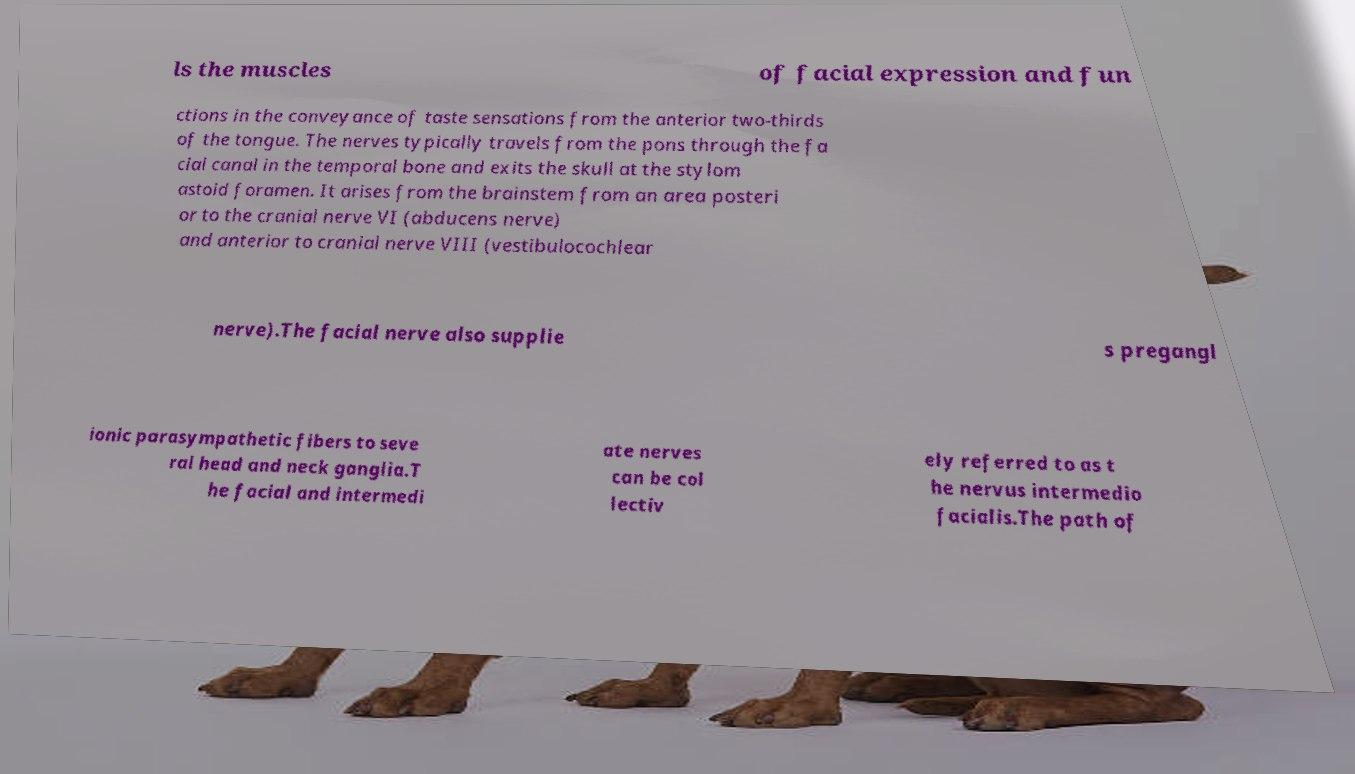Can you accurately transcribe the text from the provided image for me? ls the muscles of facial expression and fun ctions in the conveyance of taste sensations from the anterior two-thirds of the tongue. The nerves typically travels from the pons through the fa cial canal in the temporal bone and exits the skull at the stylom astoid foramen. It arises from the brainstem from an area posteri or to the cranial nerve VI (abducens nerve) and anterior to cranial nerve VIII (vestibulocochlear nerve).The facial nerve also supplie s pregangl ionic parasympathetic fibers to seve ral head and neck ganglia.T he facial and intermedi ate nerves can be col lectiv ely referred to as t he nervus intermedio facialis.The path of 